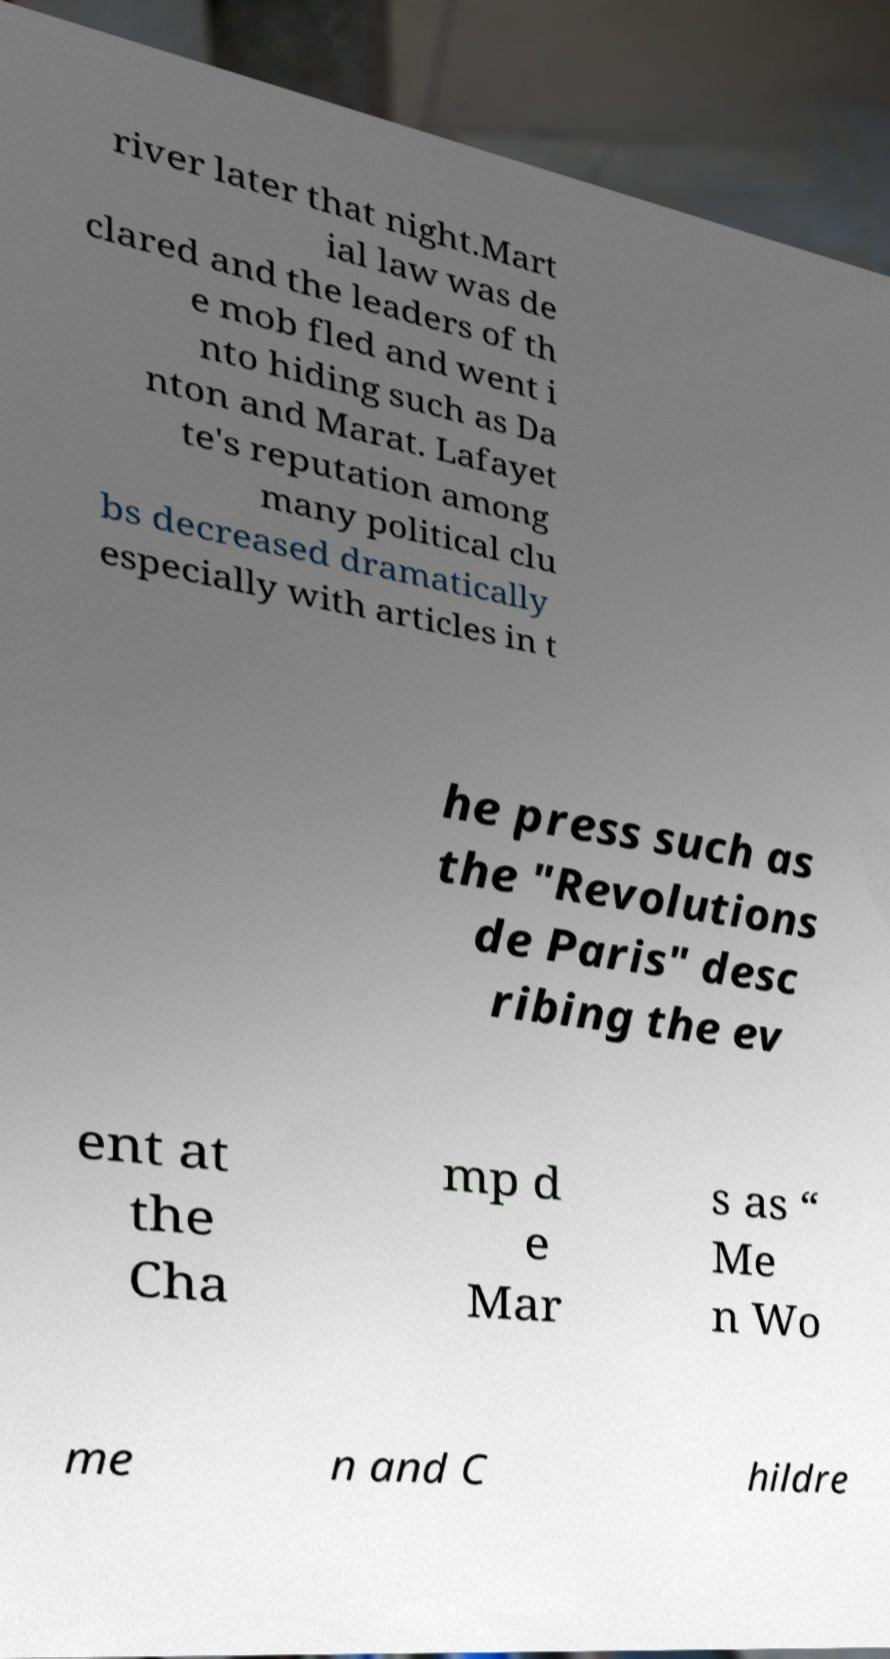Could you assist in decoding the text presented in this image and type it out clearly? river later that night.Mart ial law was de clared and the leaders of th e mob fled and went i nto hiding such as Da nton and Marat. Lafayet te's reputation among many political clu bs decreased dramatically especially with articles in t he press such as the "Revolutions de Paris" desc ribing the ev ent at the Cha mp d e Mar s as “ Me n Wo me n and C hildre 